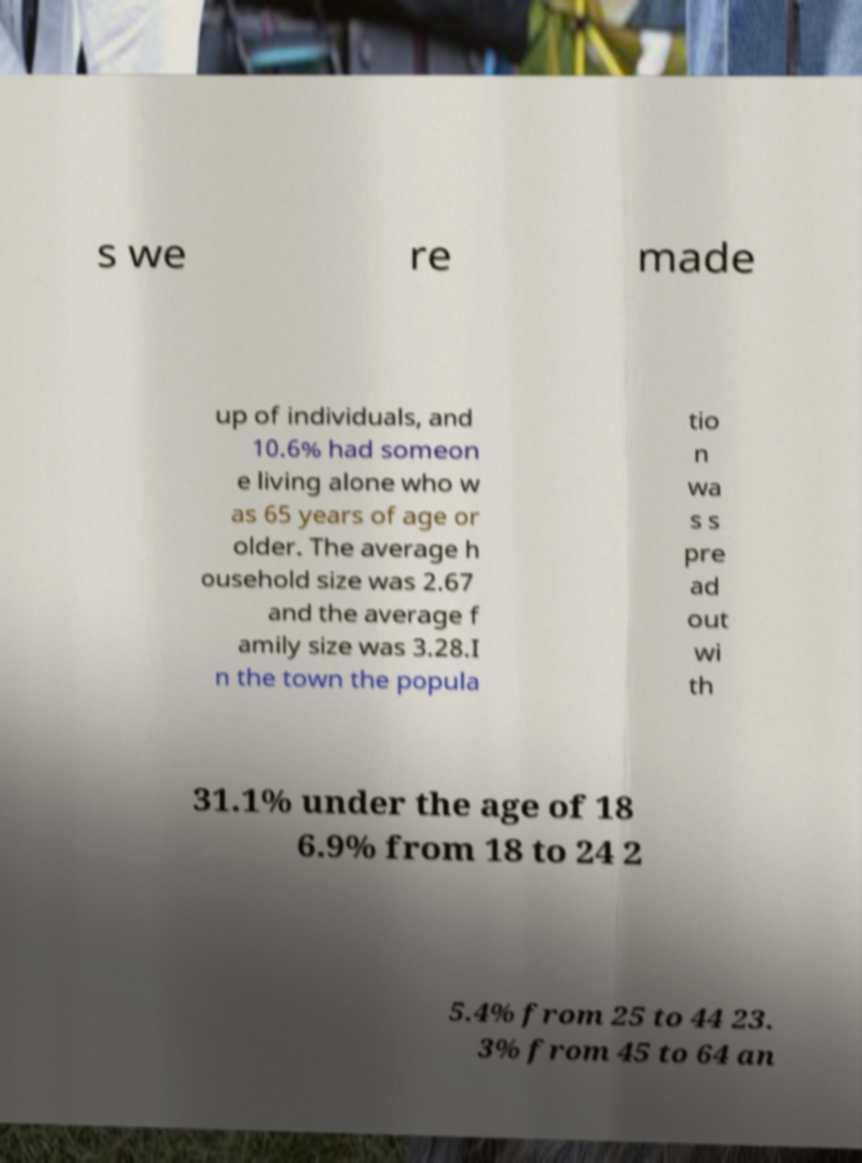Can you accurately transcribe the text from the provided image for me? s we re made up of individuals, and 10.6% had someon e living alone who w as 65 years of age or older. The average h ousehold size was 2.67 and the average f amily size was 3.28.I n the town the popula tio n wa s s pre ad out wi th 31.1% under the age of 18 6.9% from 18 to 24 2 5.4% from 25 to 44 23. 3% from 45 to 64 an 